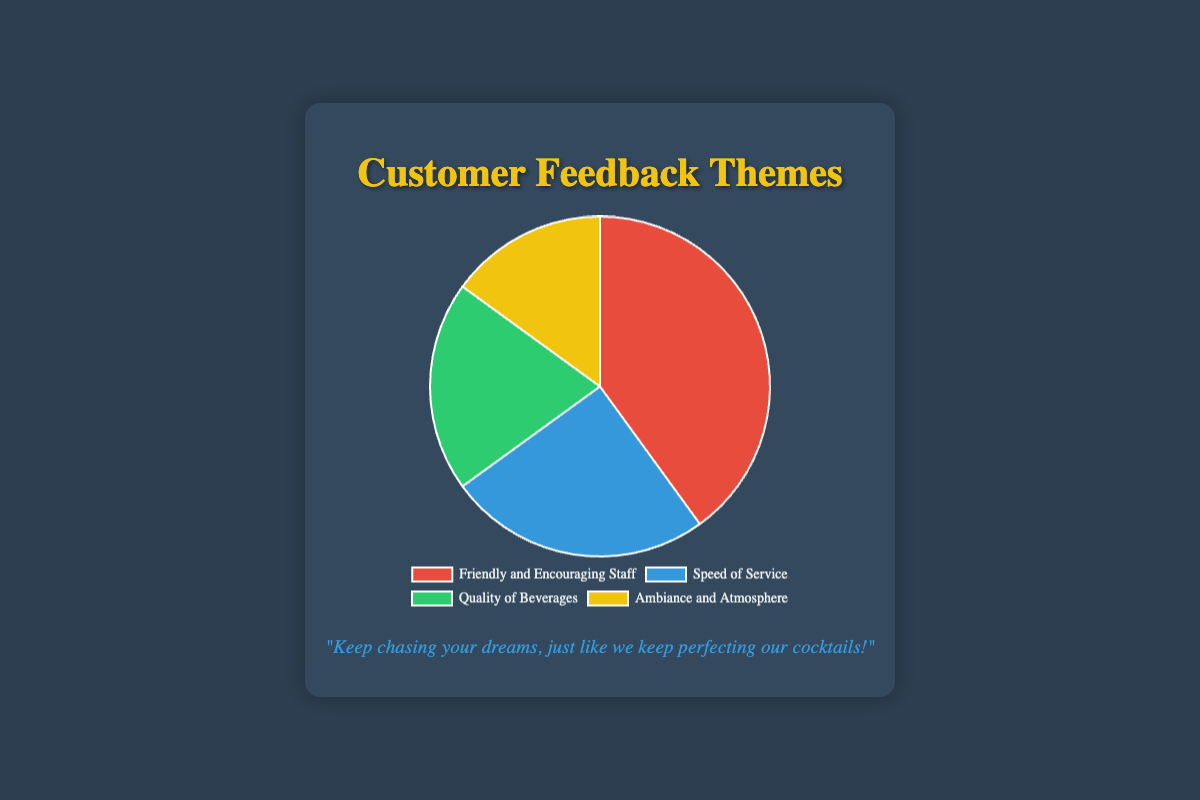What percentage of feedback is related to "Speed of Service"? Find the segment labeled "Speed of Service" in the pie chart, and note its corresponding percentage value.
Answer: 25% Which feedback theme received the least attention? Compare the percentages for each theme in the pie chart. The theme with the smallest percentage is "Ambiance and Atmosphere".
Answer: Ambiance and Atmosphere How much more feedback is related to "Friendly and Encouraging Staff" compared to "Quality of Beverages"? Subtract the percentage for "Quality of Beverages" from the percentage for "Friendly and Encouraging Staff". 40% - 20% = 20%
Answer: 20% What is the combined percentage of feedback related to "Speed of Service" and "Quality of Beverages"? Add the percentages for "Speed of Service" and "Quality of Beverages". 25% + 20% = 45%
Answer: 45% Is the percentage of feedback related to "Ambiance and Atmosphere" higher or lower than the percentage related to "Speed of Service"? Compare the percentages of "Ambiance and Atmosphere" and "Speed of Service". 15% is lower than 25%.
Answer: Lower What is the difference in percentage between "Friendly and Encouraging Staff" and "Ambiance and Atmosphere"? Subtract the percentage for "Ambiance and Atmosphere" from the percentage for "Friendly and Encouraging Staff". 40% - 15% = 25%
Answer: 25% How many themes have a percentage of 20% or higher? Count the themes where the percentage is 20% or higher: "Friendly and Encouraging Staff" (40%), "Speed of Service" (25%), "Quality of Beverages" (20%).
Answer: 3 Which theme is represented by the green color in the pie chart? Identify the theme associated with the green color segment in the pie chart. The green segment corresponds to the theme "Quality of Beverages".
Answer: Quality of Beverages What is the percentage difference between the highest and lowest feedback themes? Subtract the percentage of the lowest theme ("Ambiance and Atmosphere") from the highest theme ("Friendly and Encouraging Staff"). 40% - 15% = 25%
Answer: 25% What portion of the feedback themes is related to "Friendly and Encouraging Staff" and "Ambiance and Atmosphere" combined? Add the percentages for "Friendly and Encouraging Staff" and "Ambiance and Atmosphere". 40% + 15% = 55%
Answer: 55% 